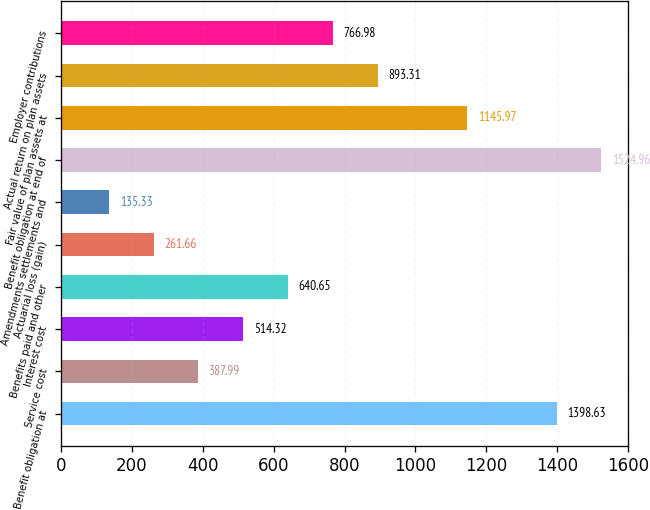<chart> <loc_0><loc_0><loc_500><loc_500><bar_chart><fcel>Benefit obligation at<fcel>Service cost<fcel>Interest cost<fcel>Benefits paid and other<fcel>Actuarial loss (gain)<fcel>Amendments settlements and<fcel>Benefit obligation at end of<fcel>Fair value of plan assets at<fcel>Actual return on plan assets<fcel>Employer contributions<nl><fcel>1398.63<fcel>387.99<fcel>514.32<fcel>640.65<fcel>261.66<fcel>135.33<fcel>1524.96<fcel>1145.97<fcel>893.31<fcel>766.98<nl></chart> 